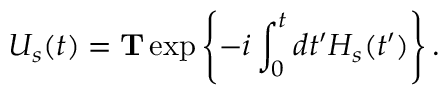Convert formula to latex. <formula><loc_0><loc_0><loc_500><loc_500>U _ { s } ( t ) = T \exp \left \{ - i \int _ { 0 } ^ { t } d t ^ { \prime } H _ { s } ( t ^ { \prime } ) \right \} .</formula> 